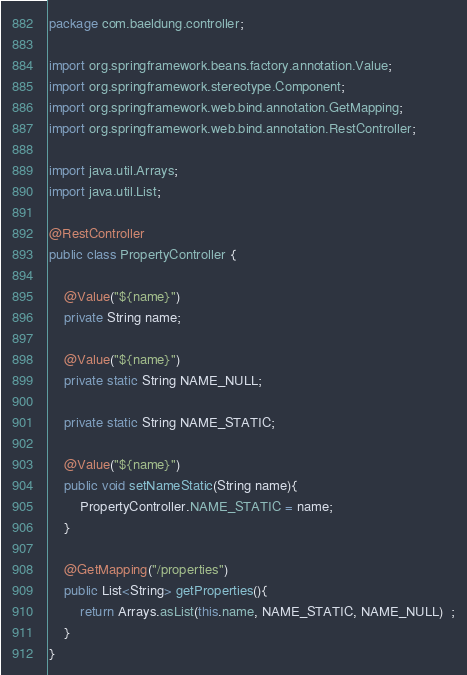<code> <loc_0><loc_0><loc_500><loc_500><_Java_>package com.baeldung.controller;

import org.springframework.beans.factory.annotation.Value;
import org.springframework.stereotype.Component;
import org.springframework.web.bind.annotation.GetMapping;
import org.springframework.web.bind.annotation.RestController;

import java.util.Arrays;
import java.util.List;

@RestController
public class PropertyController {

    @Value("${name}")
    private String name;

    @Value("${name}")
    private static String NAME_NULL;

    private static String NAME_STATIC;

    @Value("${name}")
    public void setNameStatic(String name){
        PropertyController.NAME_STATIC = name;
    }

    @GetMapping("/properties")
    public List<String> getProperties(){
        return Arrays.asList(this.name, NAME_STATIC, NAME_NULL)  ;
    }
}
</code> 